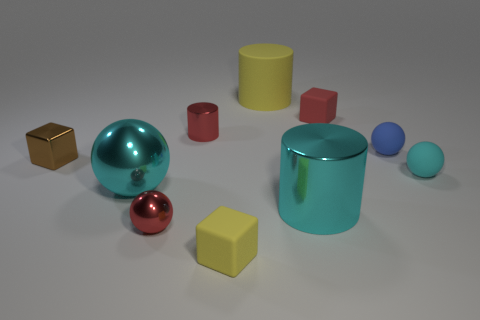Subtract all cyan cylinders. How many cylinders are left? 2 Subtract all brown blocks. How many blocks are left? 2 Subtract all cylinders. How many objects are left? 7 Subtract 1 cubes. How many cubes are left? 2 Subtract all yellow spheres. Subtract all gray cubes. How many spheres are left? 4 Subtract all red balls. How many yellow cylinders are left? 1 Subtract all red matte things. Subtract all small red cylinders. How many objects are left? 8 Add 1 cyan shiny objects. How many cyan shiny objects are left? 3 Add 3 big blue metallic spheres. How many big blue metallic spheres exist? 3 Subtract 1 red cubes. How many objects are left? 9 